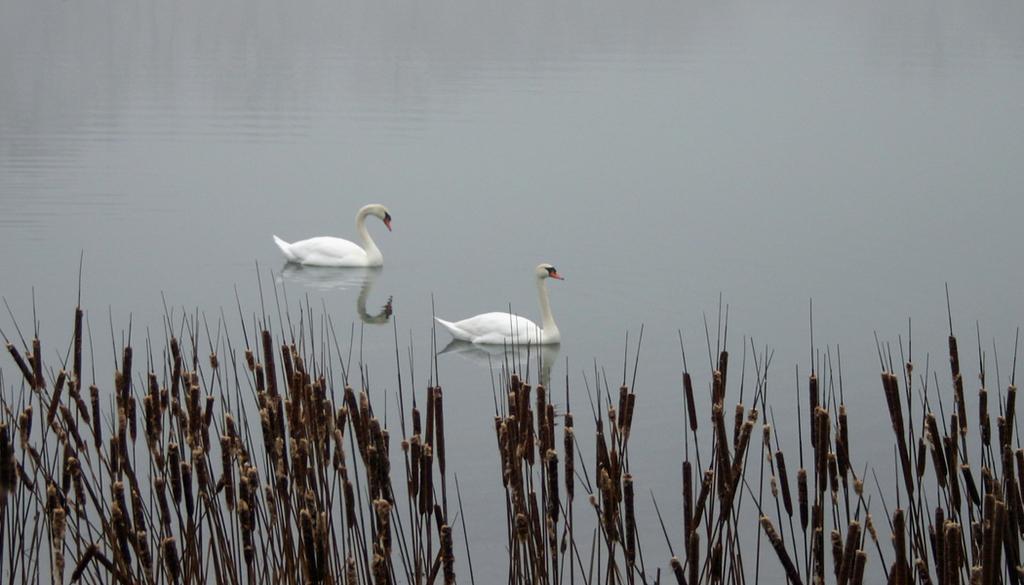Could you give a brief overview of what you see in this image? In this image I can see the plants. To the side of the plants I can see two birds on the water. These birds are in white color. 